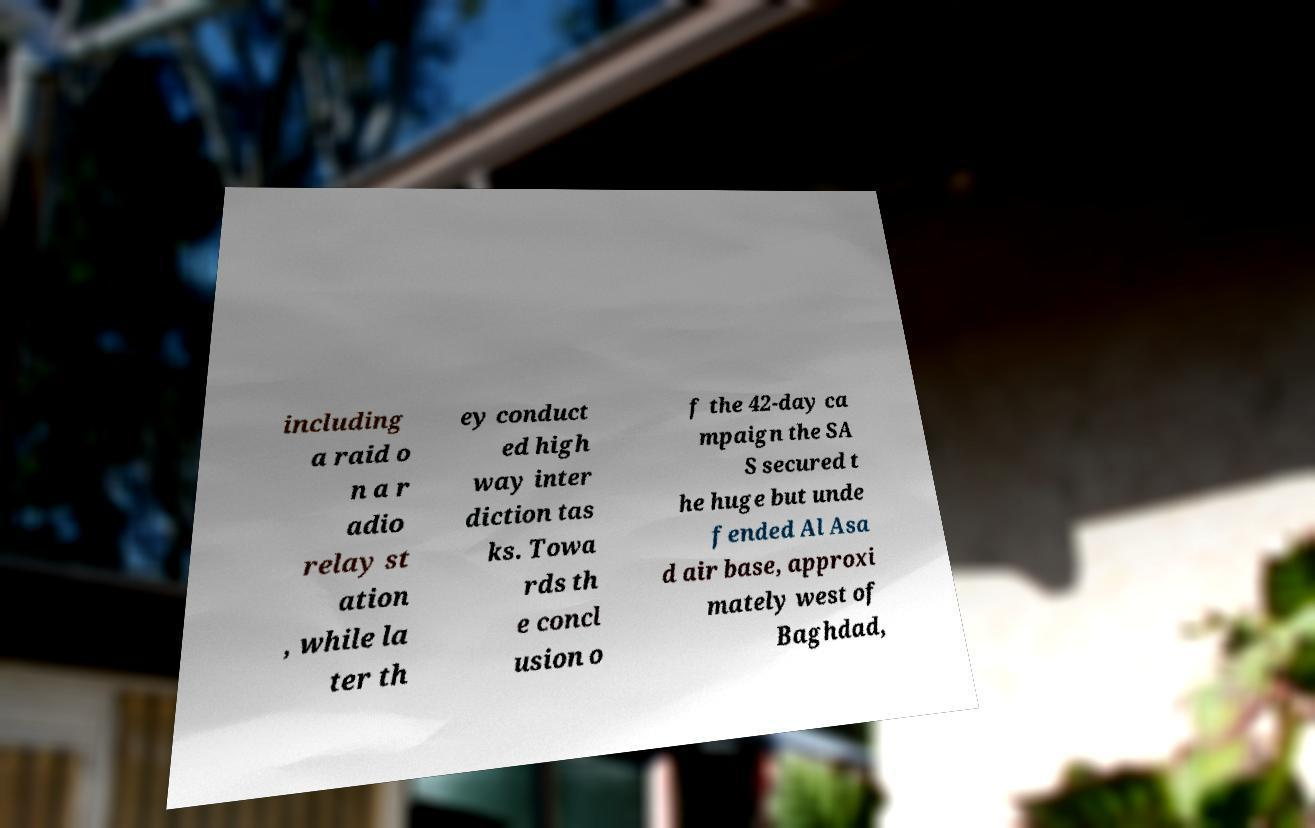What messages or text are displayed in this image? I need them in a readable, typed format. including a raid o n a r adio relay st ation , while la ter th ey conduct ed high way inter diction tas ks. Towa rds th e concl usion o f the 42-day ca mpaign the SA S secured t he huge but unde fended Al Asa d air base, approxi mately west of Baghdad, 